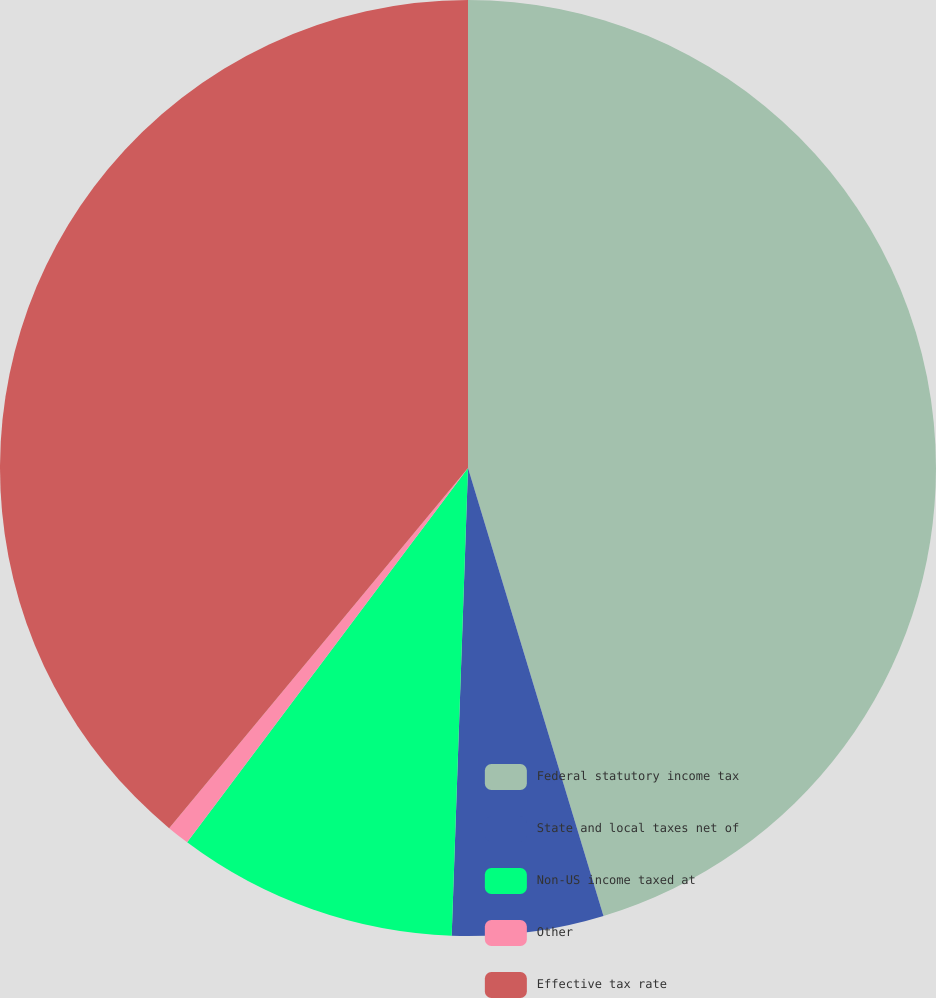Convert chart. <chart><loc_0><loc_0><loc_500><loc_500><pie_chart><fcel>Federal statutory income tax<fcel>State and local taxes net of<fcel>Non-US income taxed at<fcel>Other<fcel>Effective tax rate<nl><fcel>45.33%<fcel>5.23%<fcel>9.69%<fcel>0.78%<fcel>38.98%<nl></chart> 